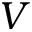Convert formula to latex. <formula><loc_0><loc_0><loc_500><loc_500>V</formula> 